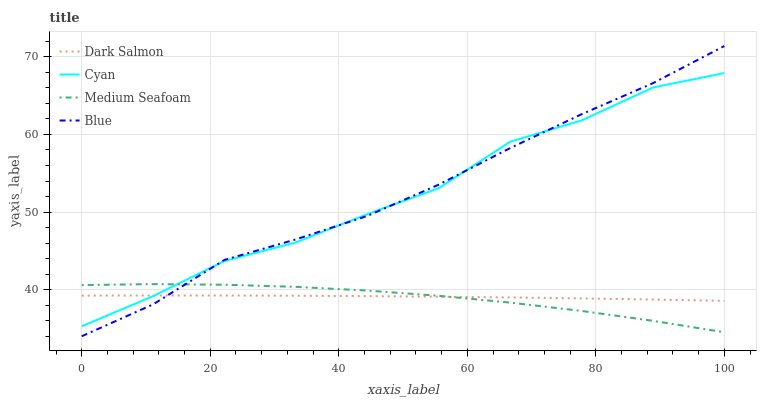Does Medium Seafoam have the minimum area under the curve?
Answer yes or no. Yes. Does Blue have the maximum area under the curve?
Answer yes or no. Yes. Does Cyan have the minimum area under the curve?
Answer yes or no. No. Does Cyan have the maximum area under the curve?
Answer yes or no. No. Is Dark Salmon the smoothest?
Answer yes or no. Yes. Is Cyan the roughest?
Answer yes or no. Yes. Is Cyan the smoothest?
Answer yes or no. No. Is Dark Salmon the roughest?
Answer yes or no. No. Does Blue have the lowest value?
Answer yes or no. Yes. Does Cyan have the lowest value?
Answer yes or no. No. Does Blue have the highest value?
Answer yes or no. Yes. Does Cyan have the highest value?
Answer yes or no. No. Does Cyan intersect Medium Seafoam?
Answer yes or no. Yes. Is Cyan less than Medium Seafoam?
Answer yes or no. No. Is Cyan greater than Medium Seafoam?
Answer yes or no. No. 